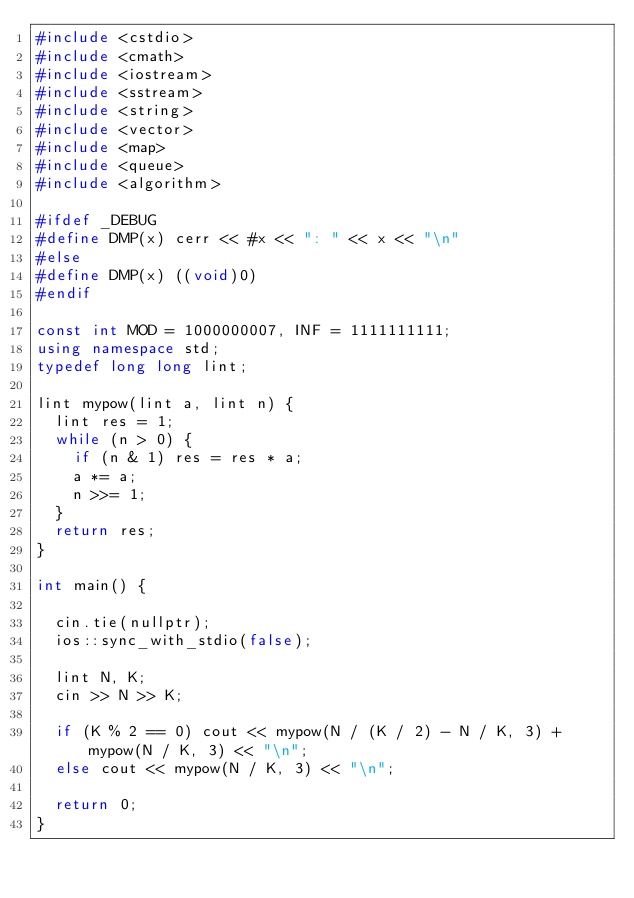<code> <loc_0><loc_0><loc_500><loc_500><_C++_>#include <cstdio>
#include <cmath>
#include <iostream>
#include <sstream>
#include <string>
#include <vector>
#include <map>
#include <queue>
#include <algorithm>

#ifdef _DEBUG
#define DMP(x) cerr << #x << ": " << x << "\n"
#else
#define DMP(x) ((void)0)
#endif

const int MOD = 1000000007, INF = 1111111111; 
using namespace std;
typedef long long lint;

lint mypow(lint a, lint n) {
	lint res = 1;
	while (n > 0) {
		if (n & 1) res = res * a;
		a *= a;
		n >>= 1;
	}
	return res;
}

int main() {

	cin.tie(nullptr);
	ios::sync_with_stdio(false);

	lint N, K;
	cin >> N >> K;

	if (K % 2 == 0) cout << mypow(N / (K / 2) - N / K, 3) + mypow(N / K, 3) << "\n";
	else cout << mypow(N / K, 3) << "\n";

	return 0;
}</code> 